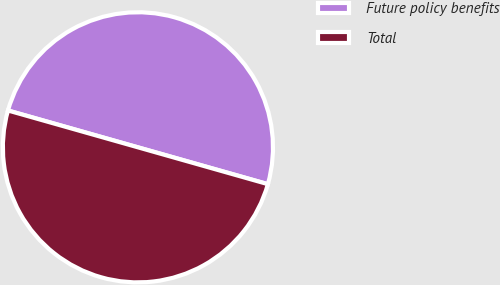Convert chart. <chart><loc_0><loc_0><loc_500><loc_500><pie_chart><fcel>Future policy benefits<fcel>Total<nl><fcel>50.0%<fcel>50.0%<nl></chart> 